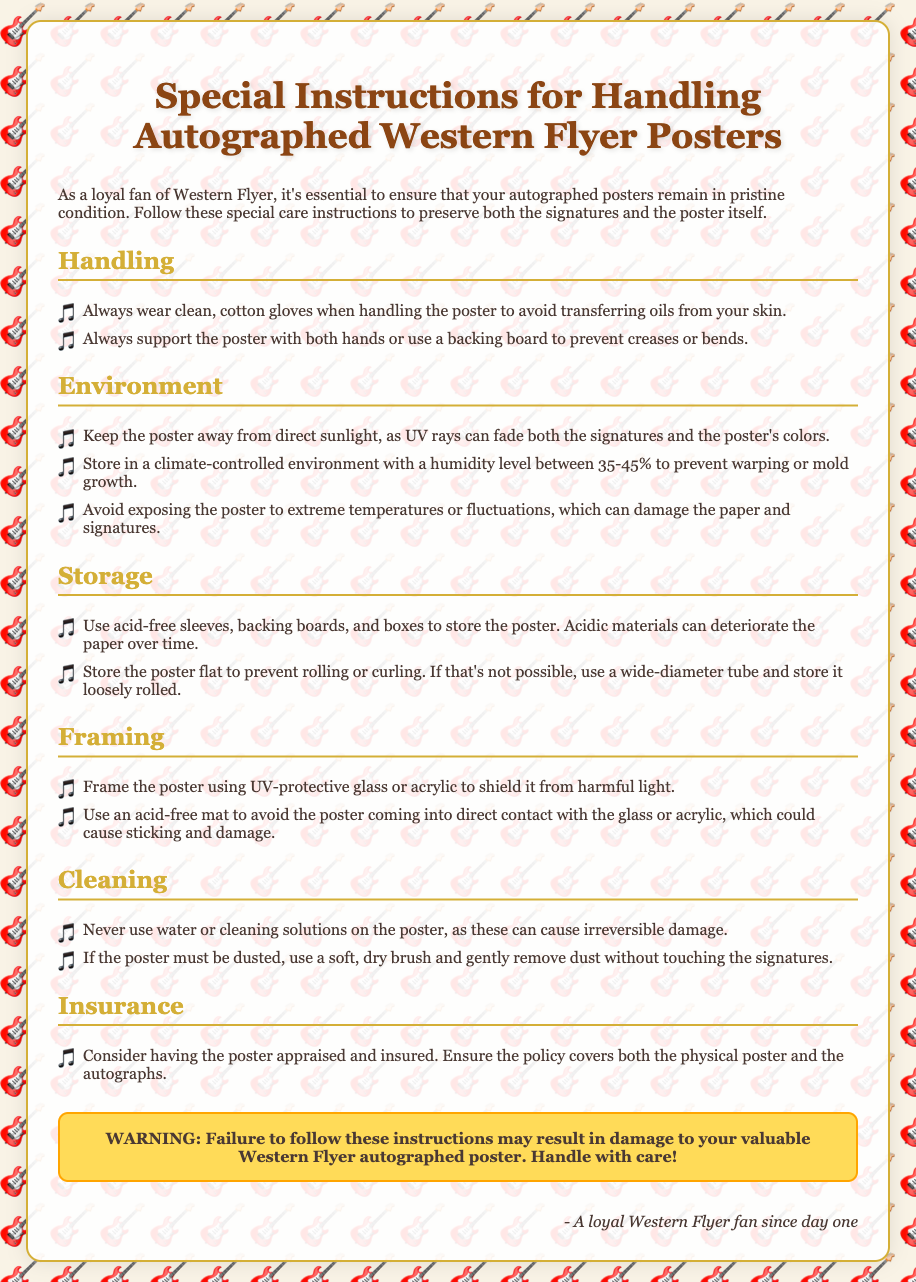what is the temperature range to avoid for storing the poster? The document specifies to avoid exposing the poster to extreme temperatures or fluctuations, which can damage the paper and signatures.
Answer: extreme temperatures how should the poster be supported during handling? The instructions state to support the poster with both hands or use a backing board to prevent creases or bends.
Answer: both hands or backing board what type of gloves should be worn when handling the poster? It is specified to wear clean, cotton gloves when handling the poster to avoid transferring oils from your skin.
Answer: clean, cotton gloves what humidity level is recommended for storing the poster? The document advises keeping a humidity level between 35-45% to prevent warping or mold growth.
Answer: 35-45% what type of glass should be used in framing the poster? It states to use UV-protective glass or acrylic to shield it from harmful light.
Answer: UV-protective glass or acrylic what should be used for dusting the poster? The document recommends using a soft, dry brush to gently remove dust without touching the signatures.
Answer: soft, dry brush what is the warning about failure to follow the instructions? The warning specifically states that failure to follow these instructions may result in damage to your valuable Western Flyer autographed poster.
Answer: damage to your valuable Western Flyer autographed poster what type of sleeves should be used for storing the poster? It indicates to use acid-free sleeves, backing boards, and boxes to store the poster.
Answer: acid-free sleeves what should be done if the poster needs dusting? The document explains that if the poster must be dusted, use a soft, dry brush and gently remove dust without touching the signatures.
Answer: soft, dry brush 